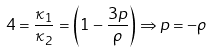Convert formula to latex. <formula><loc_0><loc_0><loc_500><loc_500>4 = \frac { \kappa _ { 1 } } { \kappa _ { 2 } } = \left ( 1 - \frac { 3 p } { \rho } \right ) \Rightarrow p = - \rho</formula> 